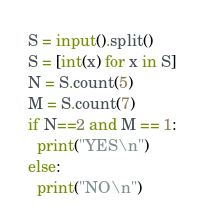Convert code to text. <code><loc_0><loc_0><loc_500><loc_500><_Python_>S = input().split()
S = [int(x) for x in S]
N = S.count(5)
M = S.count(7)
if N==2 and M == 1:
  print("YES\n")
else:
  print("NO\n")</code> 